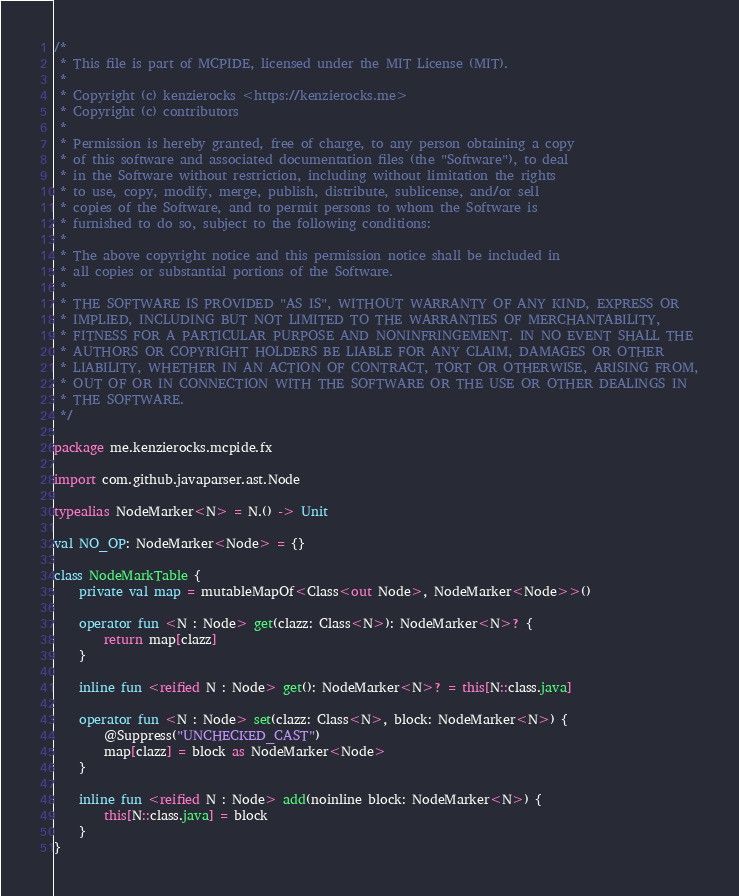Convert code to text. <code><loc_0><loc_0><loc_500><loc_500><_Kotlin_>/*
 * This file is part of MCPIDE, licensed under the MIT License (MIT).
 *
 * Copyright (c) kenzierocks <https://kenzierocks.me>
 * Copyright (c) contributors
 *
 * Permission is hereby granted, free of charge, to any person obtaining a copy
 * of this software and associated documentation files (the "Software"), to deal
 * in the Software without restriction, including without limitation the rights
 * to use, copy, modify, merge, publish, distribute, sublicense, and/or sell
 * copies of the Software, and to permit persons to whom the Software is
 * furnished to do so, subject to the following conditions:
 *
 * The above copyright notice and this permission notice shall be included in
 * all copies or substantial portions of the Software.
 *
 * THE SOFTWARE IS PROVIDED "AS IS", WITHOUT WARRANTY OF ANY KIND, EXPRESS OR
 * IMPLIED, INCLUDING BUT NOT LIMITED TO THE WARRANTIES OF MERCHANTABILITY,
 * FITNESS FOR A PARTICULAR PURPOSE AND NONINFRINGEMENT. IN NO EVENT SHALL THE
 * AUTHORS OR COPYRIGHT HOLDERS BE LIABLE FOR ANY CLAIM, DAMAGES OR OTHER
 * LIABILITY, WHETHER IN AN ACTION OF CONTRACT, TORT OR OTHERWISE, ARISING FROM,
 * OUT OF OR IN CONNECTION WITH THE SOFTWARE OR THE USE OR OTHER DEALINGS IN
 * THE SOFTWARE.
 */

package me.kenzierocks.mcpide.fx

import com.github.javaparser.ast.Node

typealias NodeMarker<N> = N.() -> Unit

val NO_OP: NodeMarker<Node> = {}

class NodeMarkTable {
    private val map = mutableMapOf<Class<out Node>, NodeMarker<Node>>()

    operator fun <N : Node> get(clazz: Class<N>): NodeMarker<N>? {
        return map[clazz]
    }

    inline fun <reified N : Node> get(): NodeMarker<N>? = this[N::class.java]

    operator fun <N : Node> set(clazz: Class<N>, block: NodeMarker<N>) {
        @Suppress("UNCHECKED_CAST")
        map[clazz] = block as NodeMarker<Node>
    }

    inline fun <reified N : Node> add(noinline block: NodeMarker<N>) {
        this[N::class.java] = block
    }
}</code> 